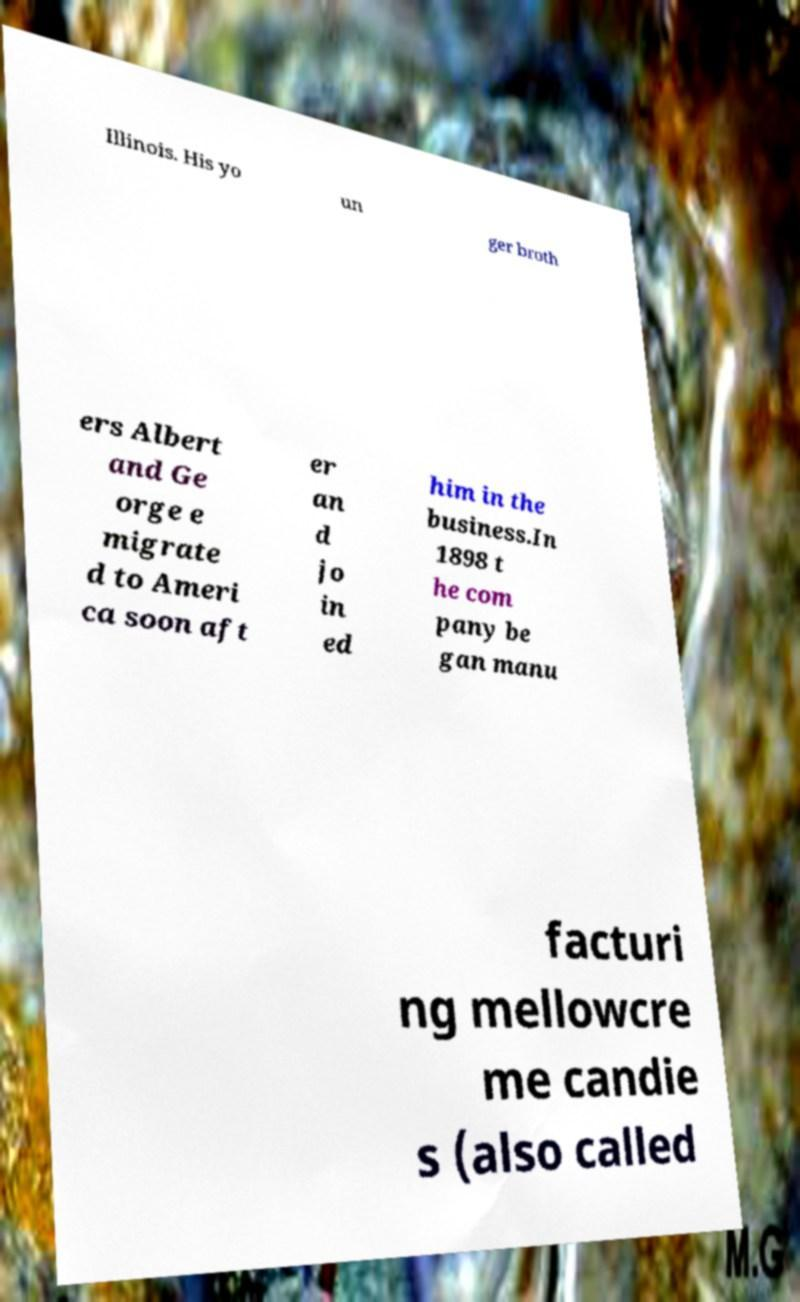What messages or text are displayed in this image? I need them in a readable, typed format. Illinois. His yo un ger broth ers Albert and Ge orge e migrate d to Ameri ca soon aft er an d jo in ed him in the business.In 1898 t he com pany be gan manu facturi ng mellowcre me candie s (also called 